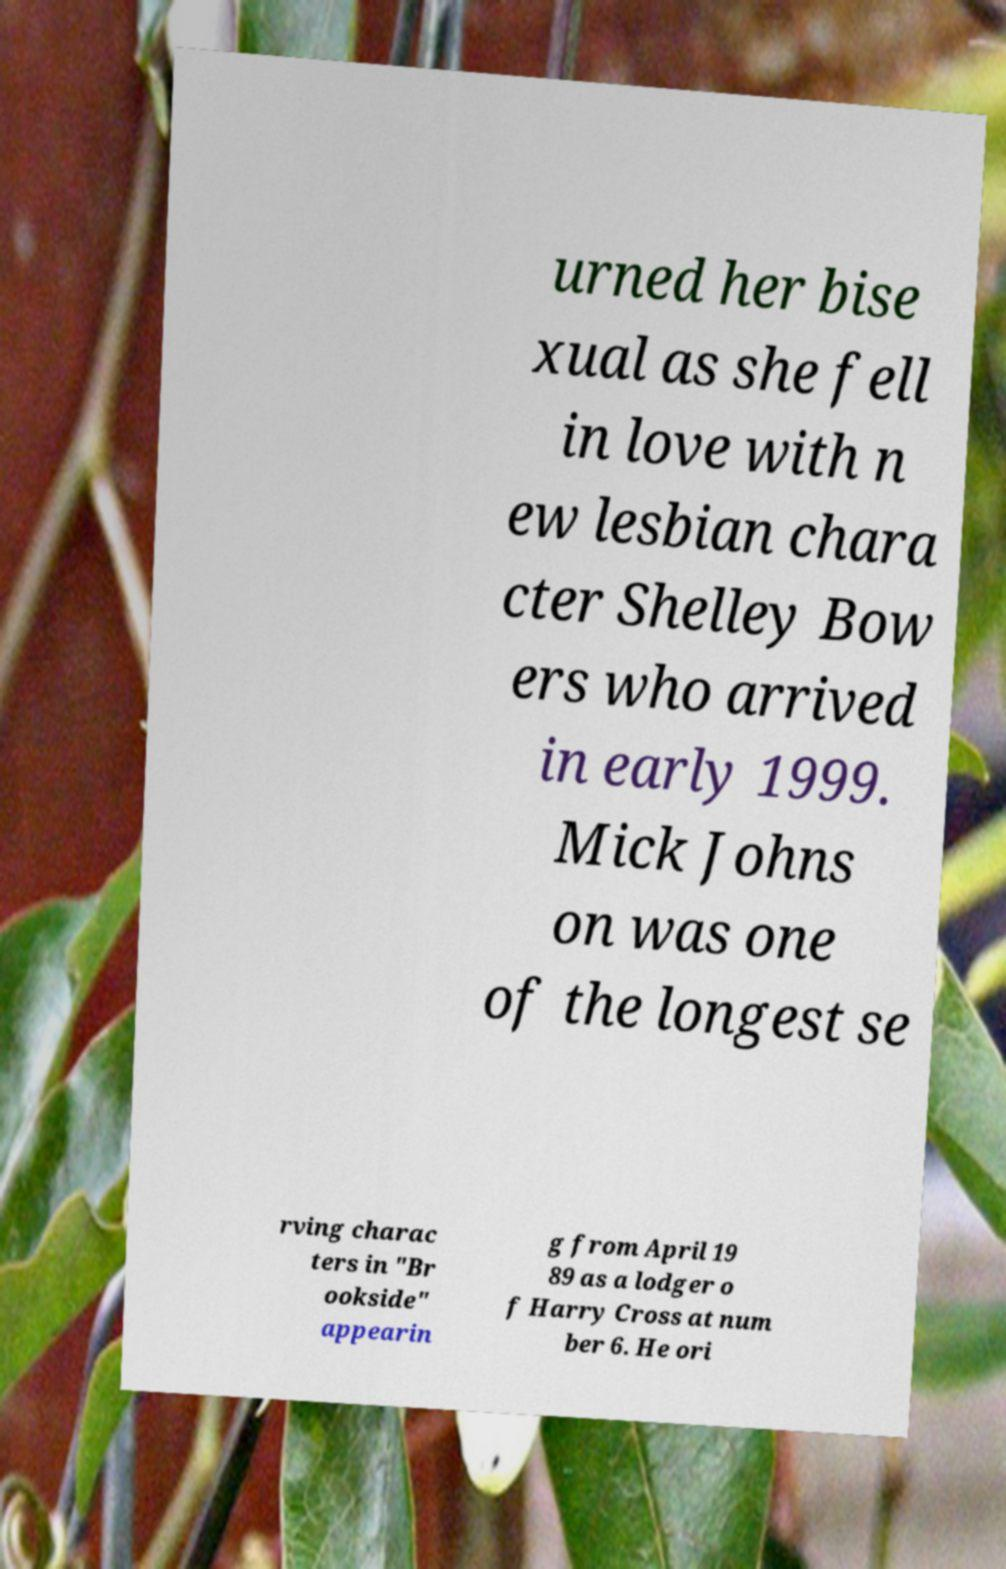I need the written content from this picture converted into text. Can you do that? urned her bise xual as she fell in love with n ew lesbian chara cter Shelley Bow ers who arrived in early 1999. Mick Johns on was one of the longest se rving charac ters in "Br ookside" appearin g from April 19 89 as a lodger o f Harry Cross at num ber 6. He ori 